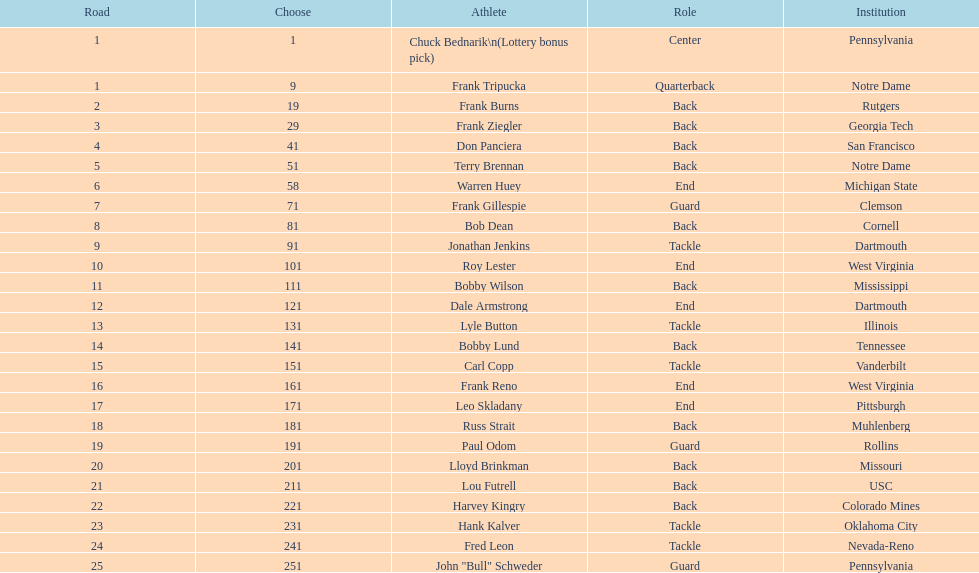Highest rd number? 25. 